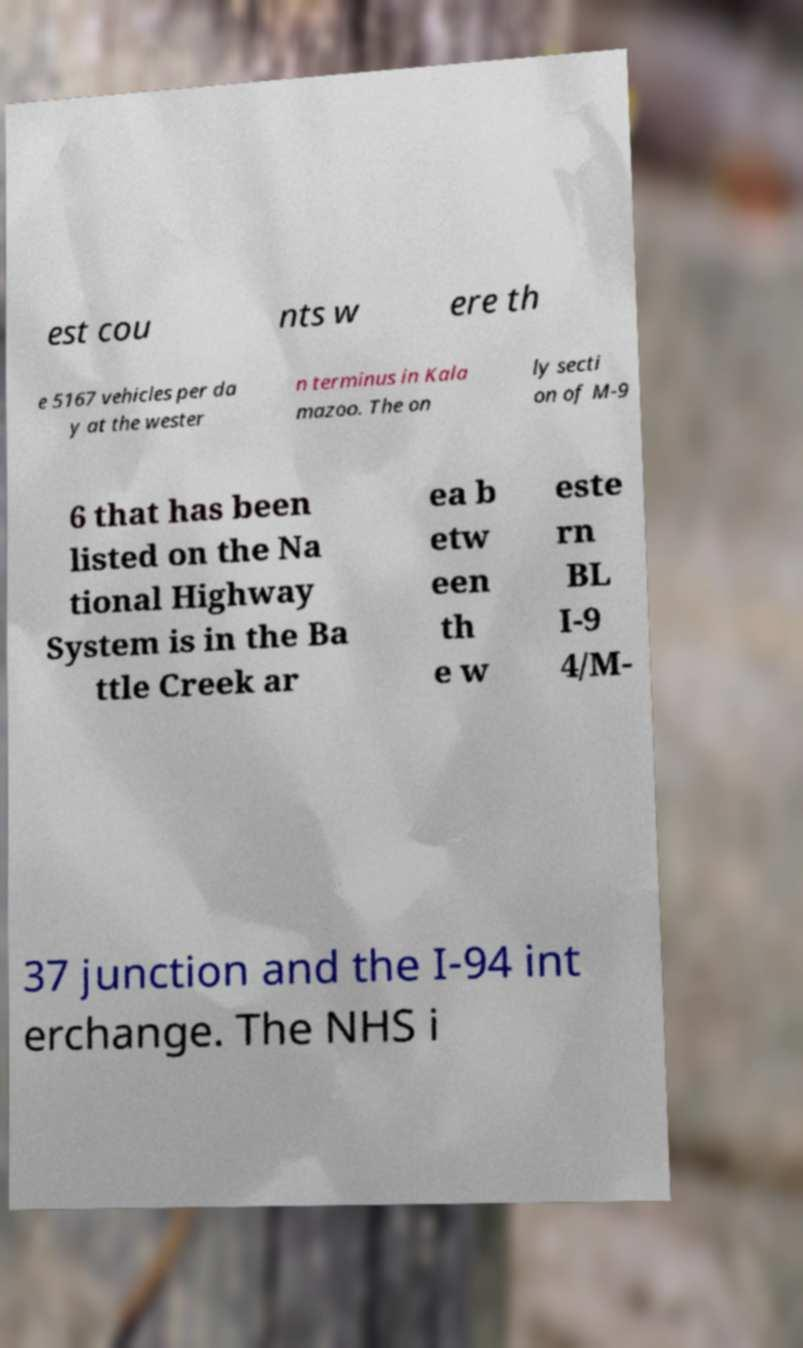What messages or text are displayed in this image? I need them in a readable, typed format. est cou nts w ere th e 5167 vehicles per da y at the wester n terminus in Kala mazoo. The on ly secti on of M-9 6 that has been listed on the Na tional Highway System is in the Ba ttle Creek ar ea b etw een th e w este rn BL I-9 4/M- 37 junction and the I-94 int erchange. The NHS i 